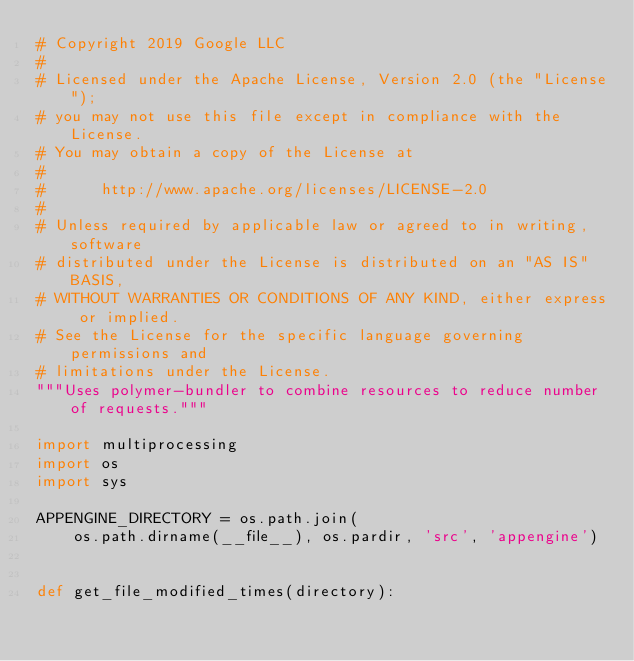<code> <loc_0><loc_0><loc_500><loc_500><_Python_># Copyright 2019 Google LLC
#
# Licensed under the Apache License, Version 2.0 (the "License");
# you may not use this file except in compliance with the License.
# You may obtain a copy of the License at
#
#      http://www.apache.org/licenses/LICENSE-2.0
#
# Unless required by applicable law or agreed to in writing, software
# distributed under the License is distributed on an "AS IS" BASIS,
# WITHOUT WARRANTIES OR CONDITIONS OF ANY KIND, either express or implied.
# See the License for the specific language governing permissions and
# limitations under the License.
"""Uses polymer-bundler to combine resources to reduce number of requests."""

import multiprocessing
import os
import sys

APPENGINE_DIRECTORY = os.path.join(
    os.path.dirname(__file__), os.pardir, 'src', 'appengine')


def get_file_modified_times(directory):</code> 